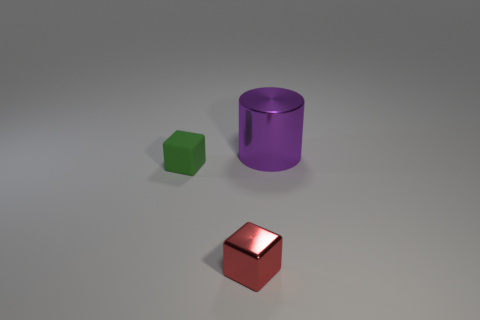Add 2 red rubber cylinders. How many objects exist? 5 Subtract all green cubes. How many cubes are left? 1 Subtract 2 blocks. How many blocks are left? 0 Add 3 purple shiny cylinders. How many purple shiny cylinders exist? 4 Subtract 0 green spheres. How many objects are left? 3 Subtract all blocks. How many objects are left? 1 Subtract all cyan cubes. Subtract all yellow spheres. How many cubes are left? 2 Subtract all tiny red rubber cylinders. Subtract all big purple shiny cylinders. How many objects are left? 2 Add 2 big purple cylinders. How many big purple cylinders are left? 3 